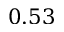<formula> <loc_0><loc_0><loc_500><loc_500>0 . 5 3</formula> 